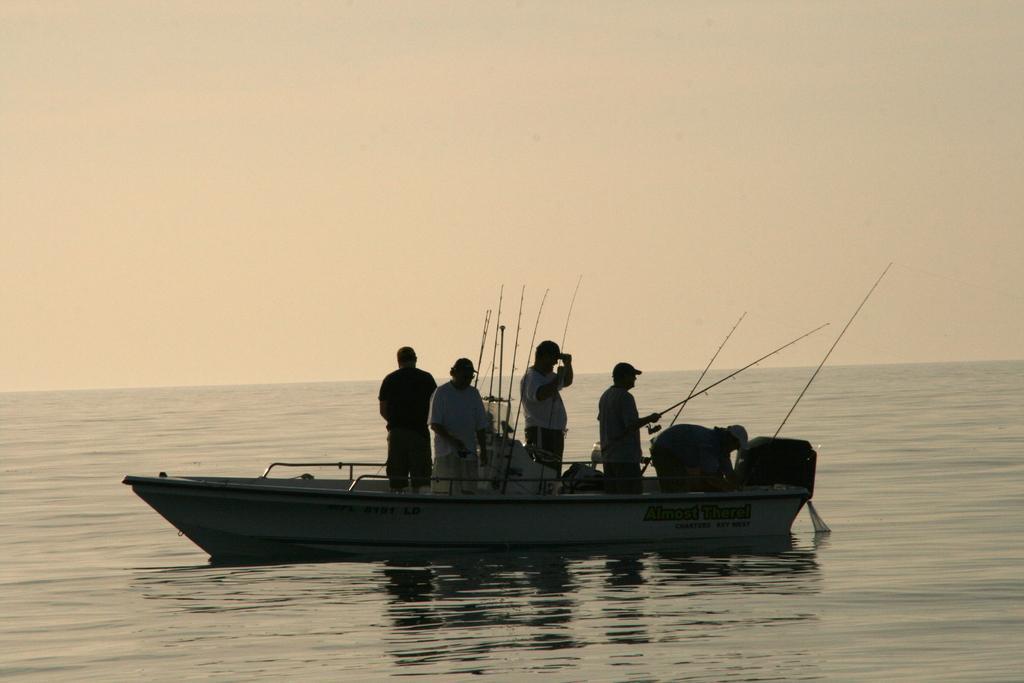How would you summarize this image in a sentence or two? In the image in the center, we can see one boat. In the boat, we can see a few people are standing and holding fishing rod. In the background we can see the sky, clouds and water. 